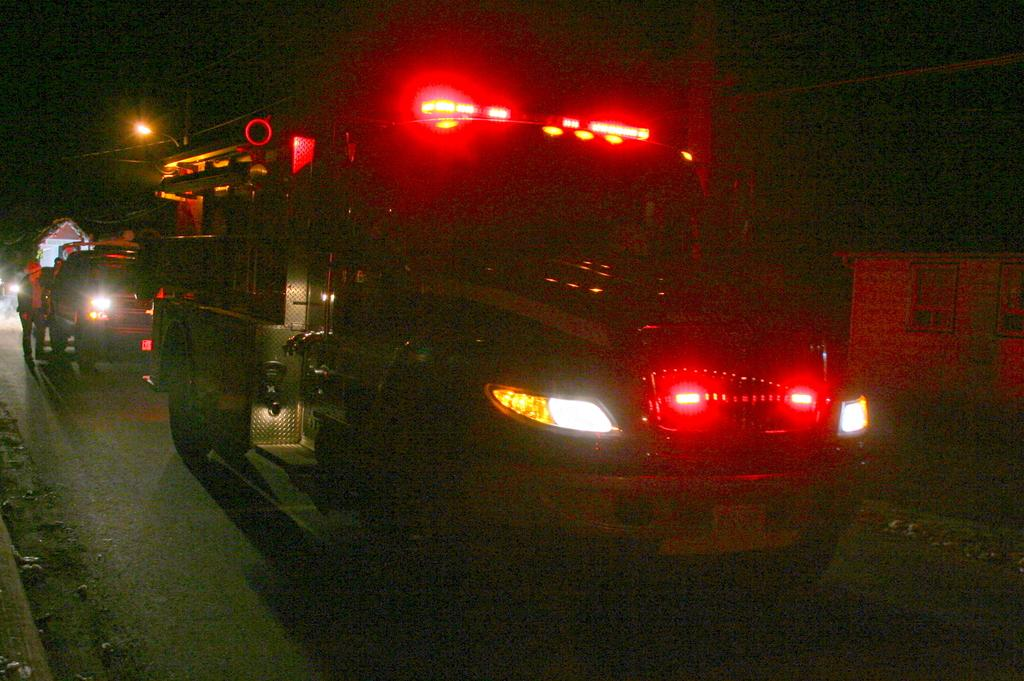How many vehicles can be seen on the road in the image? There are two vehicles on the road in the image. Can you describe the people visible in the image? There are people visible in the image, but their specific actions or characteristics are not mentioned in the provided facts. What type of structures can be seen in the image? There are houses in the image. What is the purpose of the street light in the image? The purpose of the street light in the image is to provide illumination for the road and surrounding area. What type of plant is growing on the street light in the image? There is no plant growing on the street light in the image. How does the light from the street light help the people in the image rest? The street light does not have a direct impact on the people's ability to rest in the image. 